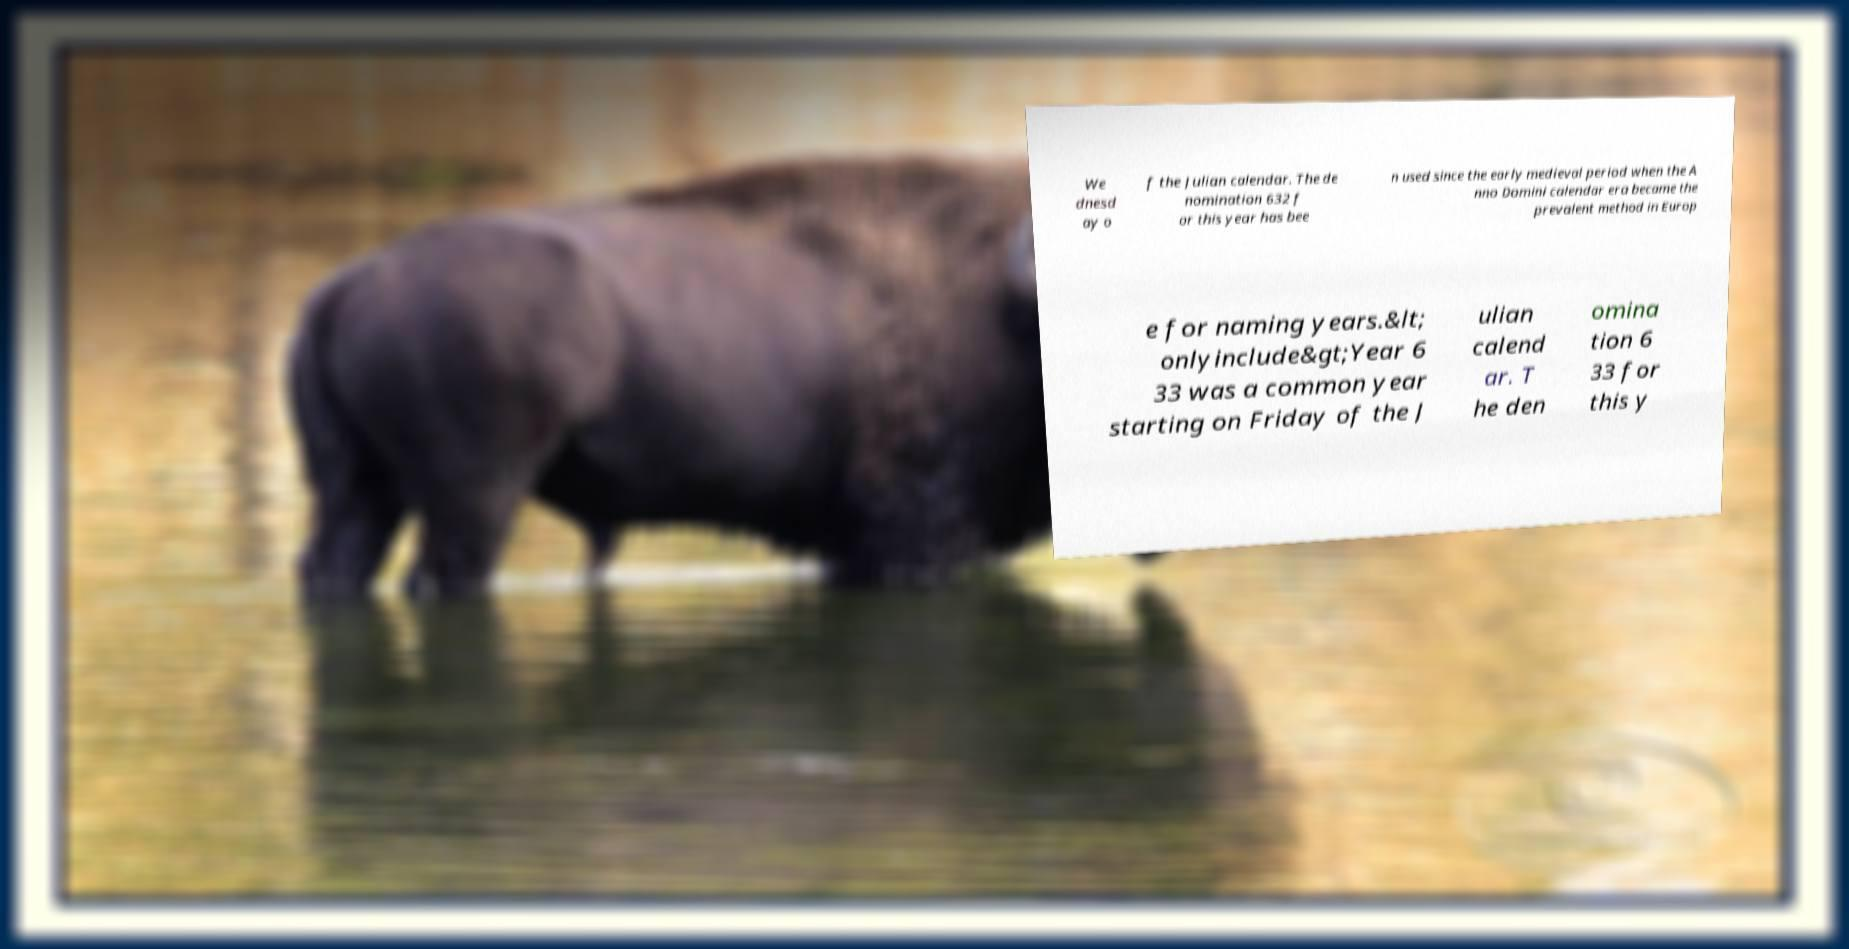What messages or text are displayed in this image? I need them in a readable, typed format. We dnesd ay o f the Julian calendar. The de nomination 632 f or this year has bee n used since the early medieval period when the A nno Domini calendar era became the prevalent method in Europ e for naming years.&lt; onlyinclude&gt;Year 6 33 was a common year starting on Friday of the J ulian calend ar. T he den omina tion 6 33 for this y 